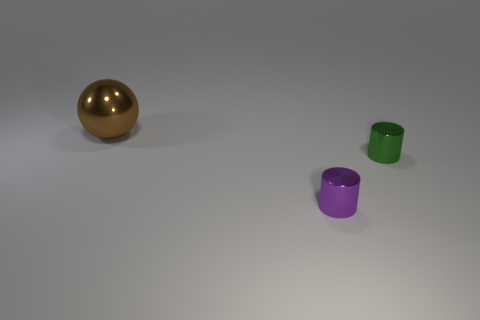What is the lighting condition in the scene? The lighting appears to be soft and diffused, coming from a direction that casts subtle shadows to the right of the objects, suggesting a singular overhead or angled light source. 